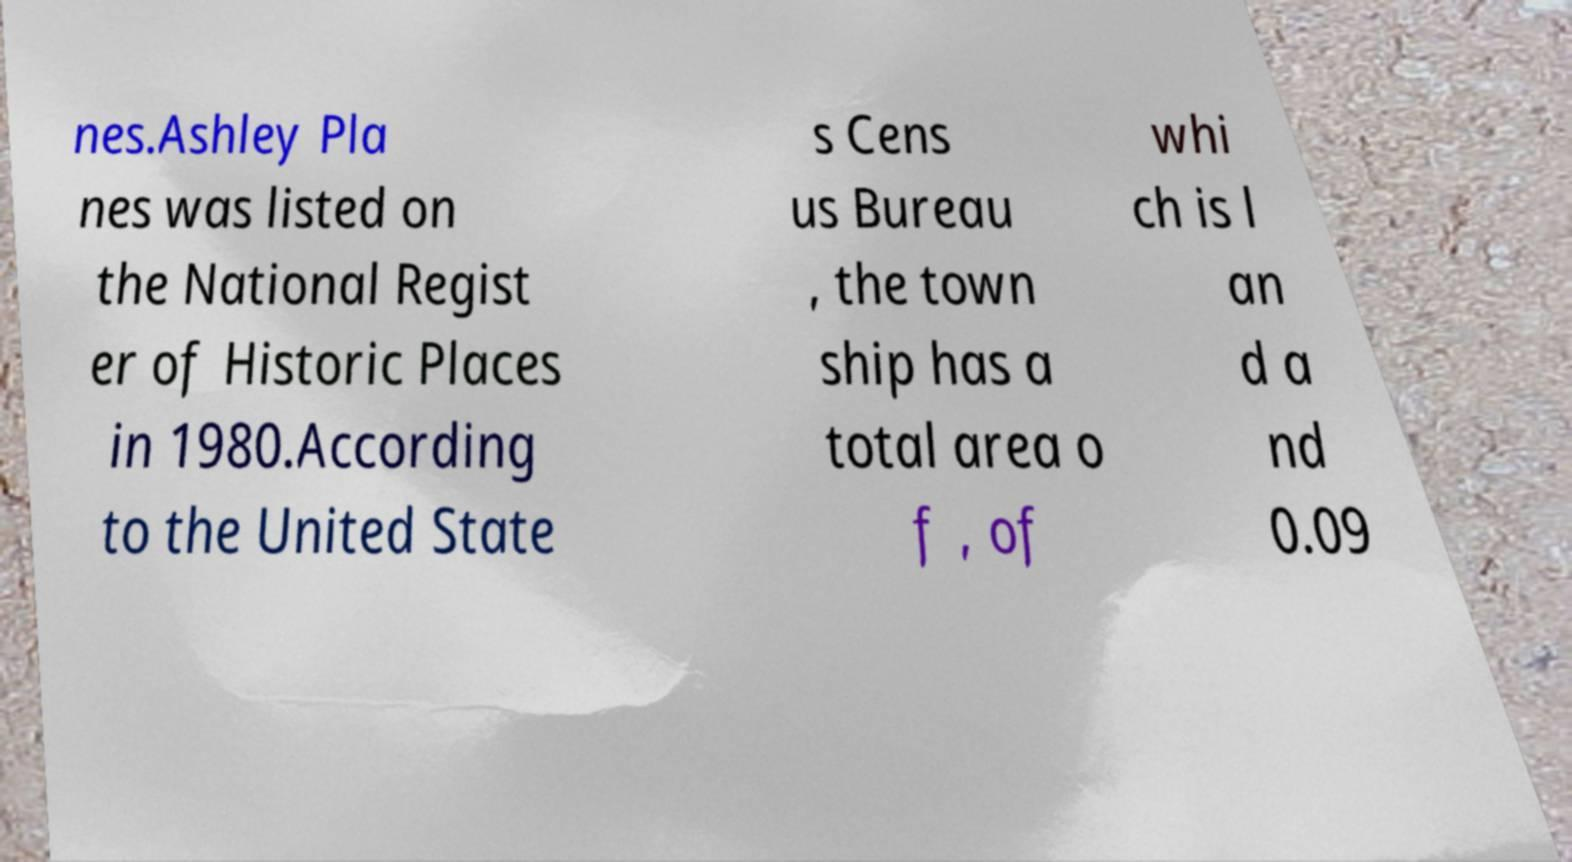Please read and relay the text visible in this image. What does it say? nes.Ashley Pla nes was listed on the National Regist er of Historic Places in 1980.According to the United State s Cens us Bureau , the town ship has a total area o f , of whi ch is l an d a nd 0.09 